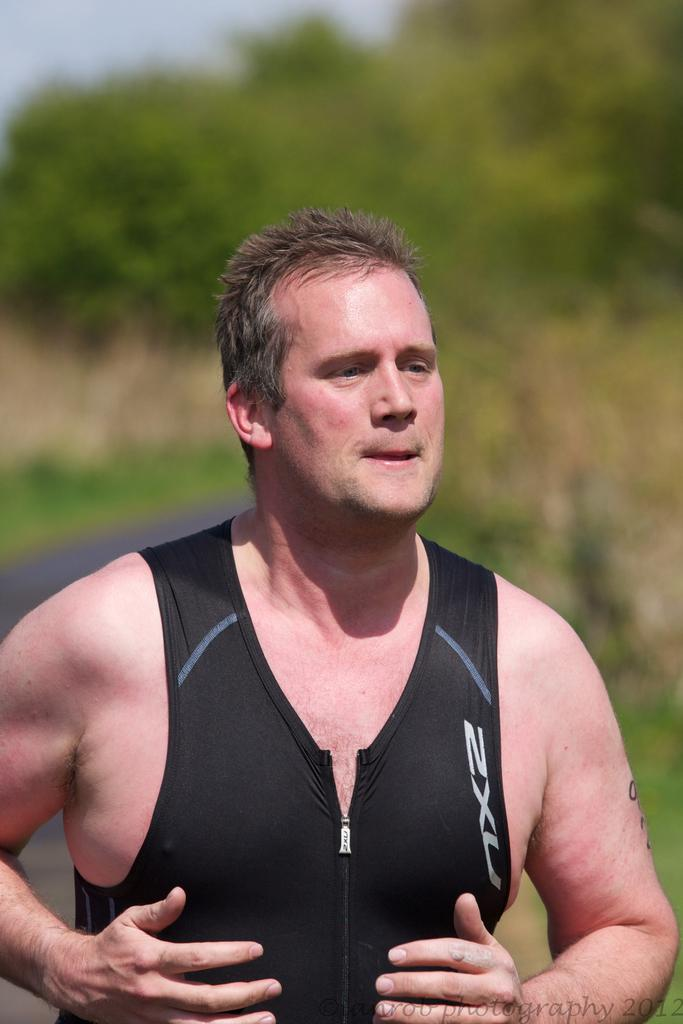<image>
Provide a brief description of the given image. A man wearing a wet suit vest outside 